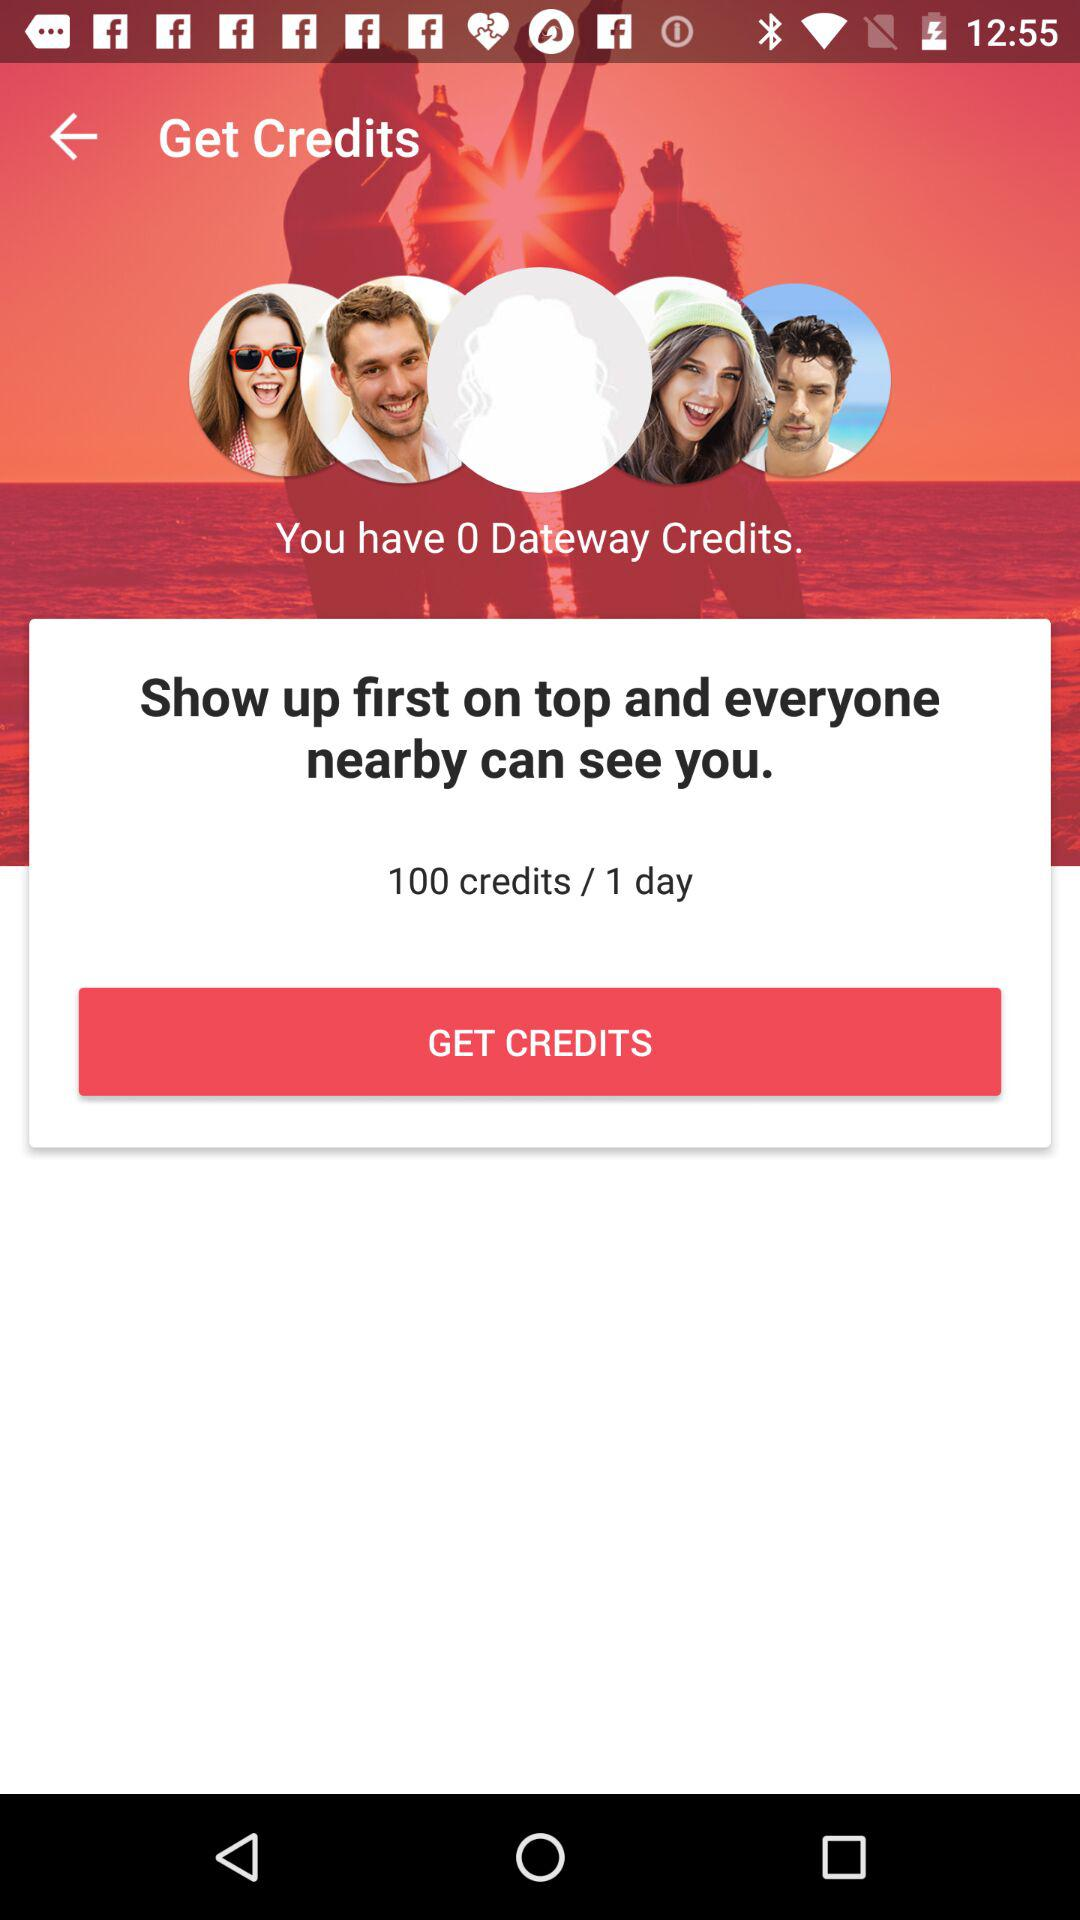How many credits do I have?
Answer the question using a single word or phrase. 0 